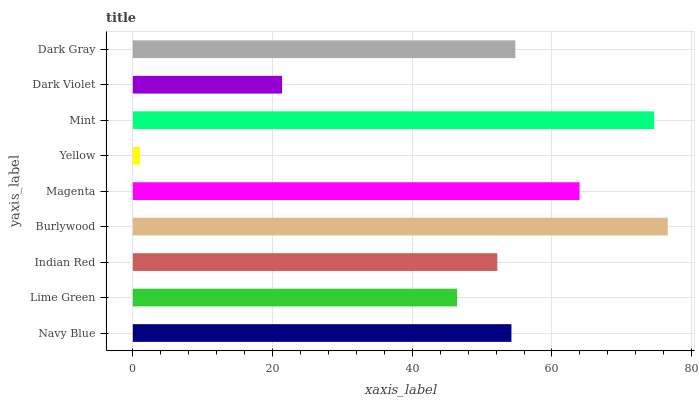Is Yellow the minimum?
Answer yes or no. Yes. Is Burlywood the maximum?
Answer yes or no. Yes. Is Lime Green the minimum?
Answer yes or no. No. Is Lime Green the maximum?
Answer yes or no. No. Is Navy Blue greater than Lime Green?
Answer yes or no. Yes. Is Lime Green less than Navy Blue?
Answer yes or no. Yes. Is Lime Green greater than Navy Blue?
Answer yes or no. No. Is Navy Blue less than Lime Green?
Answer yes or no. No. Is Navy Blue the high median?
Answer yes or no. Yes. Is Navy Blue the low median?
Answer yes or no. Yes. Is Yellow the high median?
Answer yes or no. No. Is Burlywood the low median?
Answer yes or no. No. 